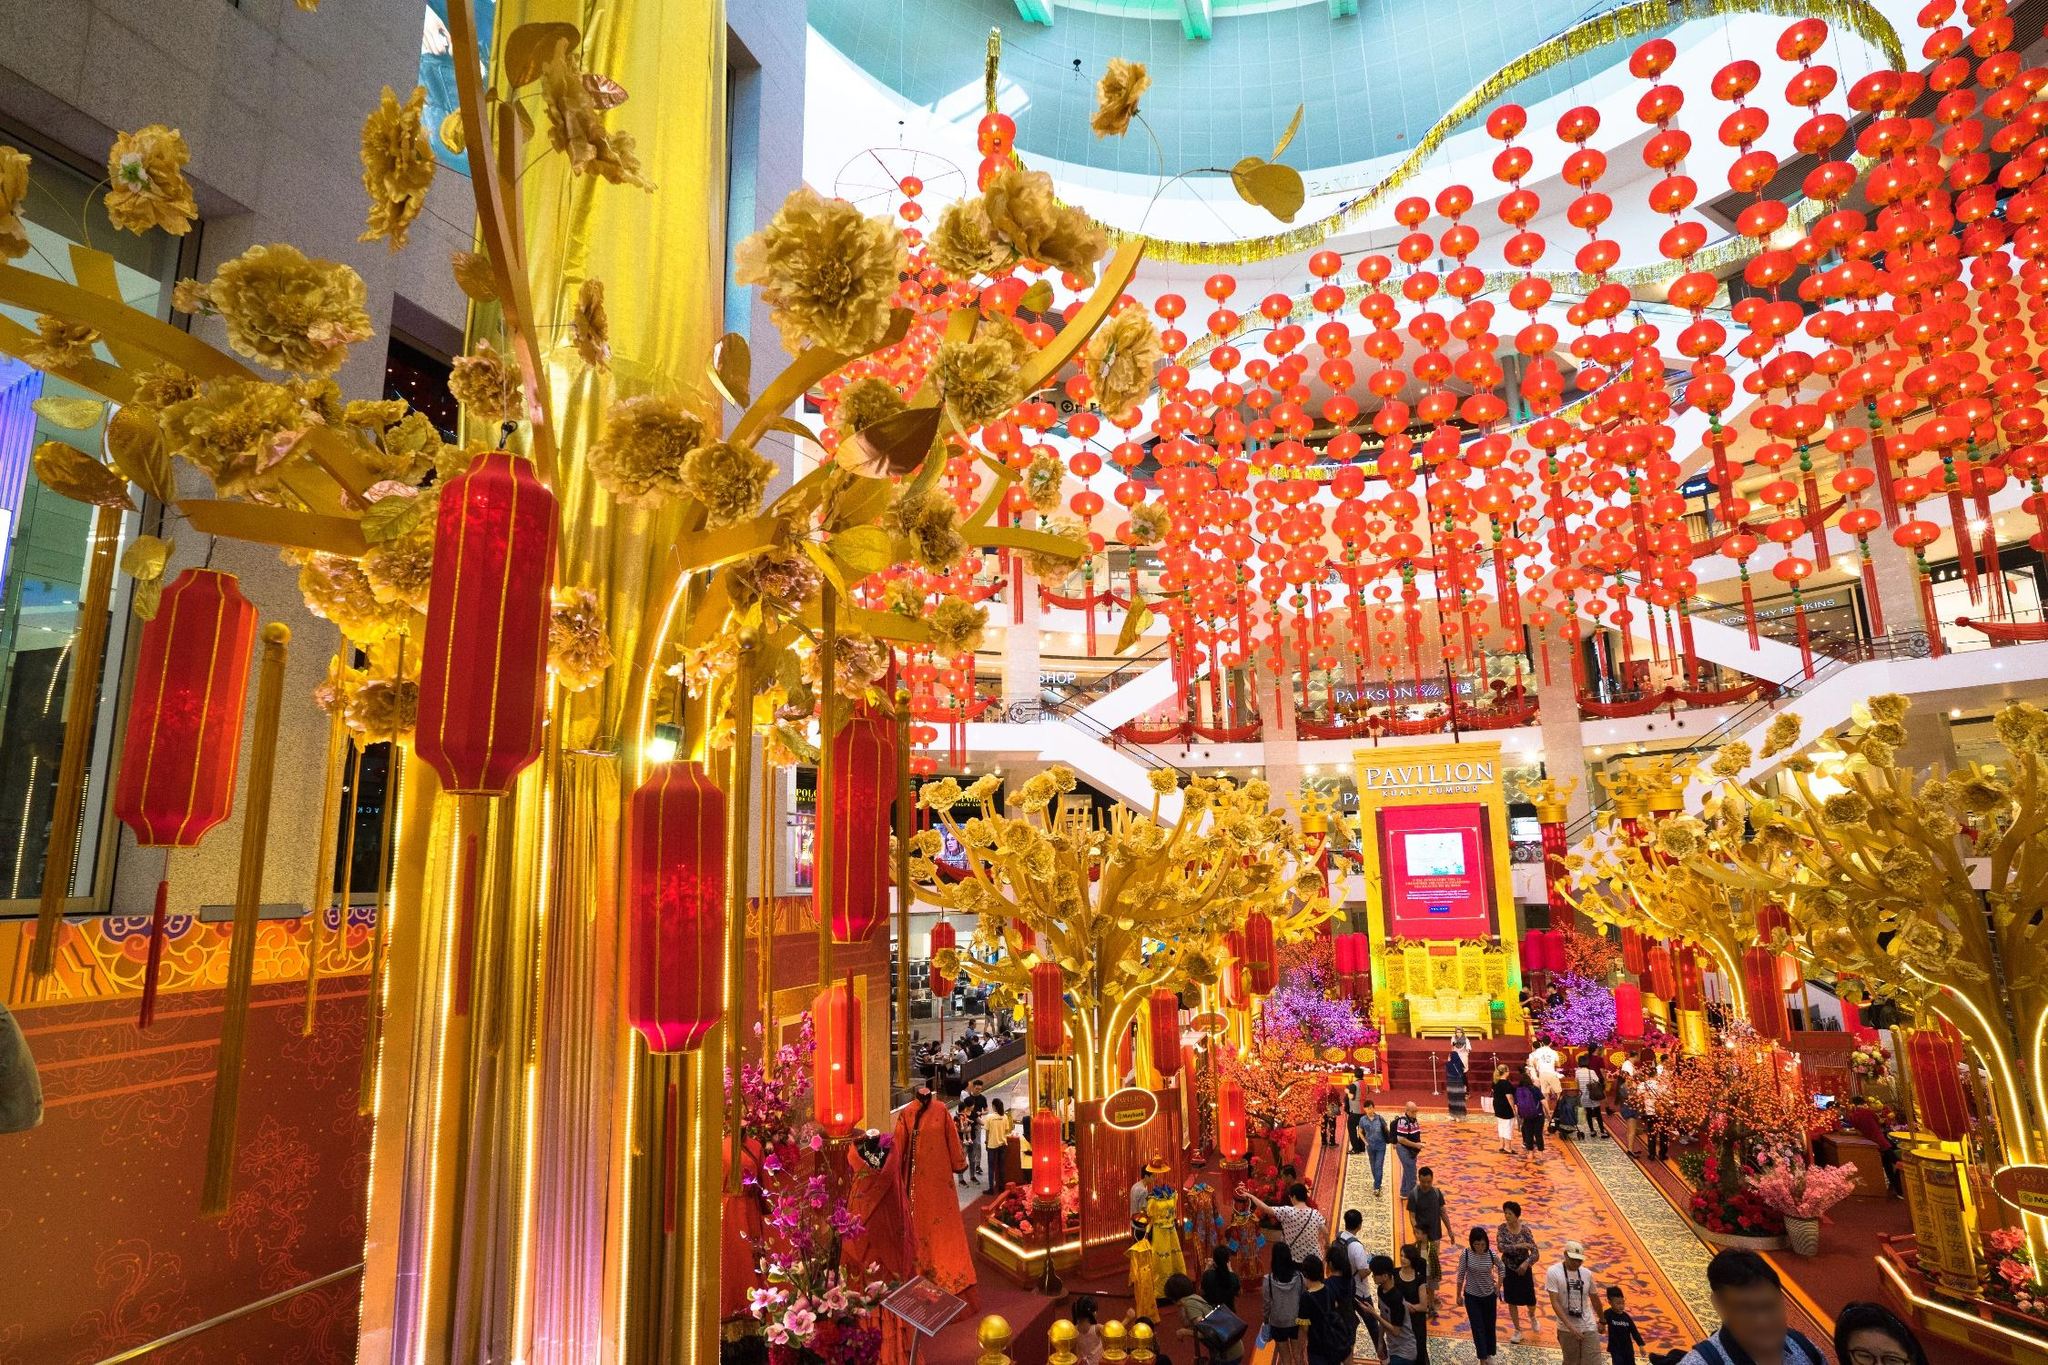What could be the occasion for such decorations in the mall? The decorations in the image are typically used during major festivals such as Chinese New Year or the Mid-Autumn Festival. The red color symbolizes good fortune and joy, while gold signifies wealth and prosperity, both of which are central themes in these celebrations. Can you tell more about the symbolic meaning of the lanterns in this context? Certainly! In many Asian cultures, lanterns are thought to ward off evil spirits and bring health and prosperity. During festivals, lanterns also symbolize the wish for a bright future and are a key component in celebrations, casting a warm and inviting light that enhances the festive mood. 